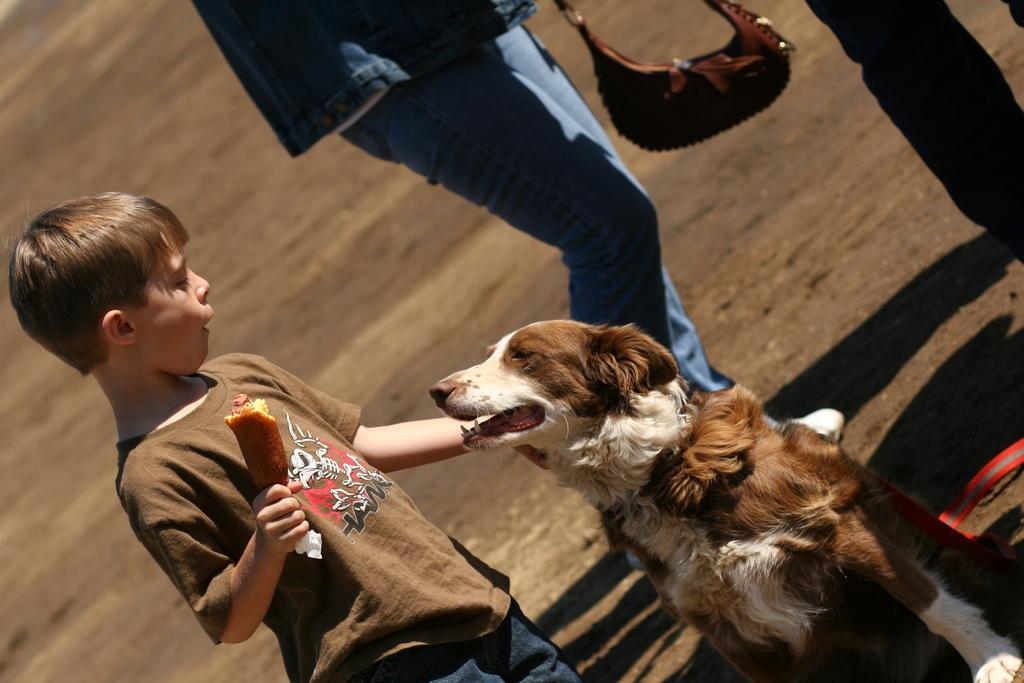What is the main subject of the image? The main subject of the image is a child. What is the child interacting with in the image? The child has a dog in front of him. What is the child holding in his hand? The child is holding something in his hand. Can you describe the person standing behind the child? There is a person standing behind the child. What else can be seen in the image? There is a bag present in the image. How many deer are visible in the image? There are no deer present in the image. What type of fruit is the child holding in the image? The child is holding something in his hand, but it is not specified as a fruit, and the type of fruit is not mentioned in the image. 